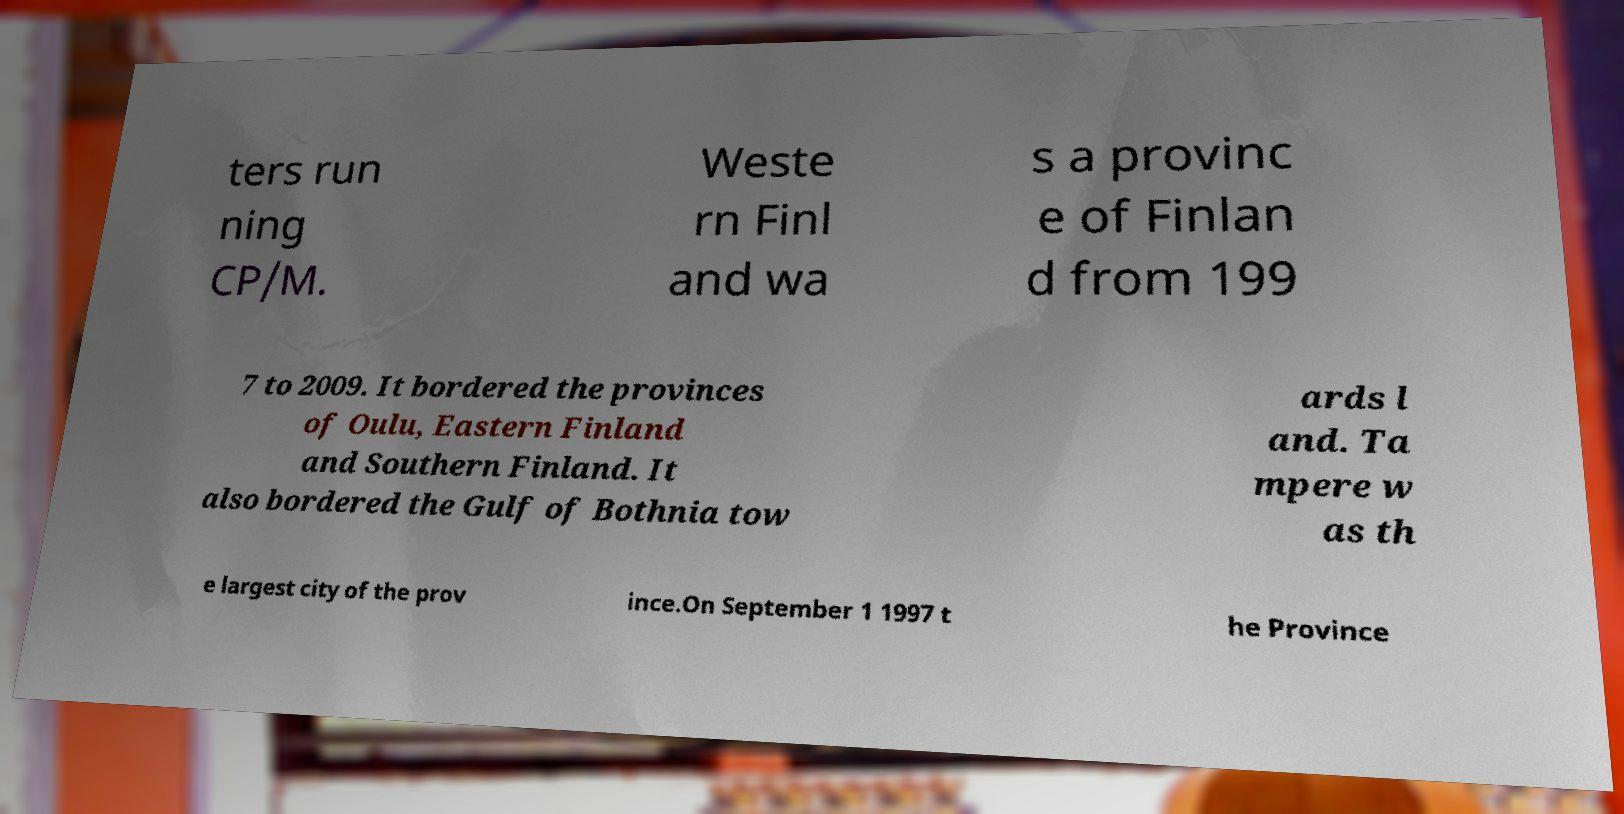What messages or text are displayed in this image? I need them in a readable, typed format. ters run ning CP/M. Weste rn Finl and wa s a provinc e of Finlan d from 199 7 to 2009. It bordered the provinces of Oulu, Eastern Finland and Southern Finland. It also bordered the Gulf of Bothnia tow ards l and. Ta mpere w as th e largest city of the prov ince.On September 1 1997 t he Province 